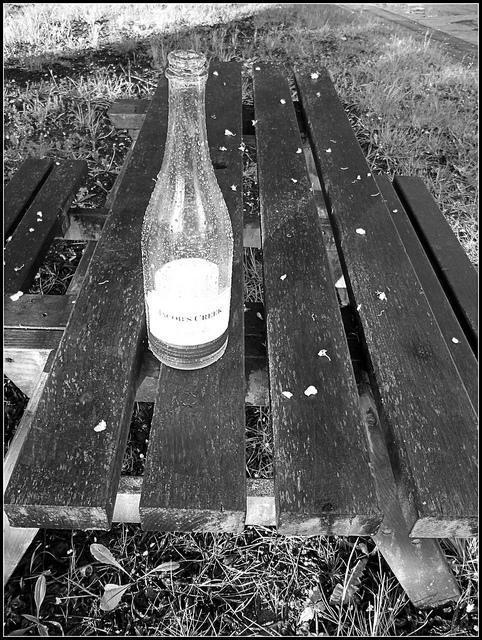Is the bottle full?
Answer briefly. No. What color is the photo?
Write a very short answer. Black and white. Is this a rest area?
Short answer required. Yes. 